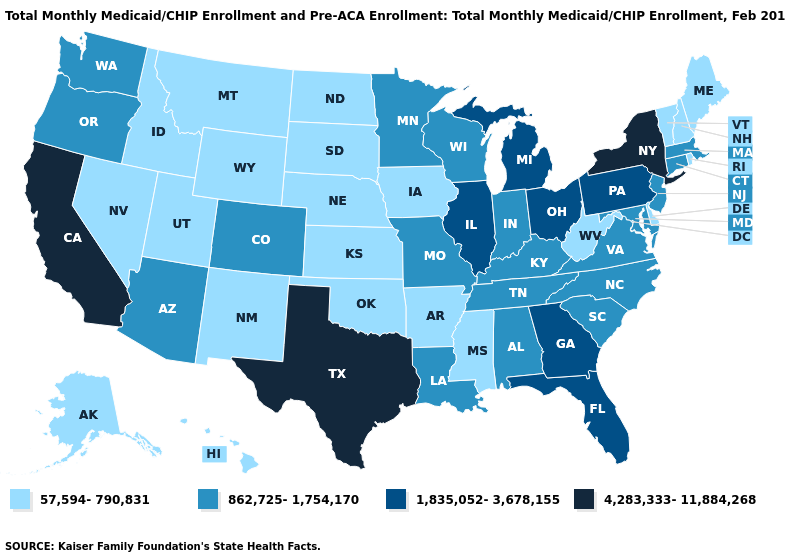Does Missouri have the lowest value in the USA?
Keep it brief. No. What is the value of North Carolina?
Answer briefly. 862,725-1,754,170. What is the lowest value in states that border Maine?
Write a very short answer. 57,594-790,831. What is the value of Nevada?
Keep it brief. 57,594-790,831. What is the lowest value in the USA?
Quick response, please. 57,594-790,831. Name the states that have a value in the range 1,835,052-3,678,155?
Be succinct. Florida, Georgia, Illinois, Michigan, Ohio, Pennsylvania. What is the lowest value in the USA?
Write a very short answer. 57,594-790,831. Does the map have missing data?
Be succinct. No. Among the states that border Virginia , does West Virginia have the lowest value?
Short answer required. Yes. What is the value of Illinois?
Concise answer only. 1,835,052-3,678,155. What is the value of Missouri?
Short answer required. 862,725-1,754,170. Which states have the highest value in the USA?
Short answer required. California, New York, Texas. Name the states that have a value in the range 1,835,052-3,678,155?
Concise answer only. Florida, Georgia, Illinois, Michigan, Ohio, Pennsylvania. What is the value of California?
Give a very brief answer. 4,283,333-11,884,268. Does Iowa have a lower value than Hawaii?
Answer briefly. No. 